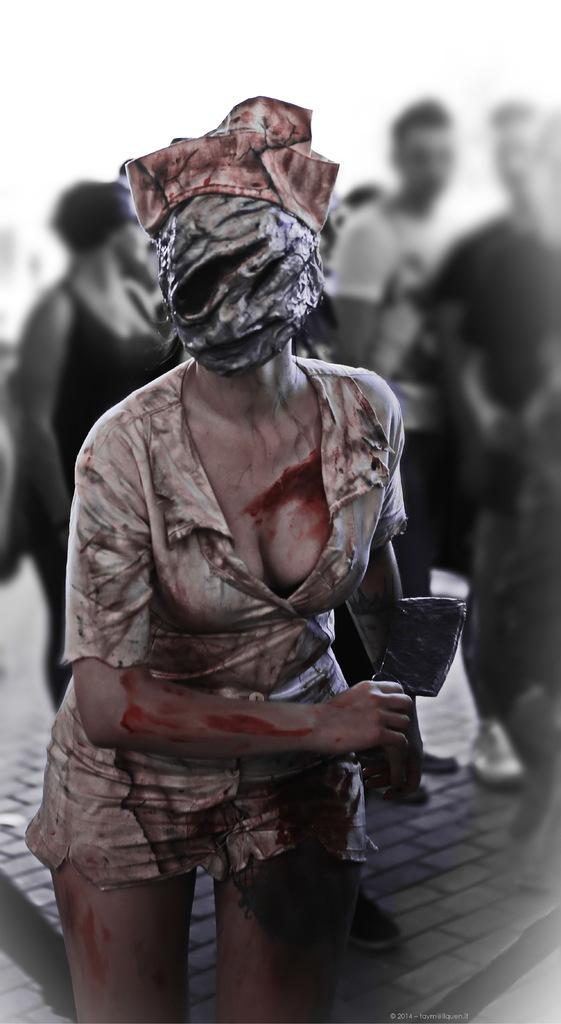Who is the main subject in the image? There is a girl in the center of the image. What is the girl wearing? The girl is wearing a costume. What is covering the girl's face? The girl has a mask on her face. Can you describe the people in the background of the image? There are other people in the background of the image. What type of gold object can be seen on the stove in the image? There is no gold object or stove present in the image. What are the girl's hobbies, as depicted in the image? The image does not provide information about the girl's hobbies. 